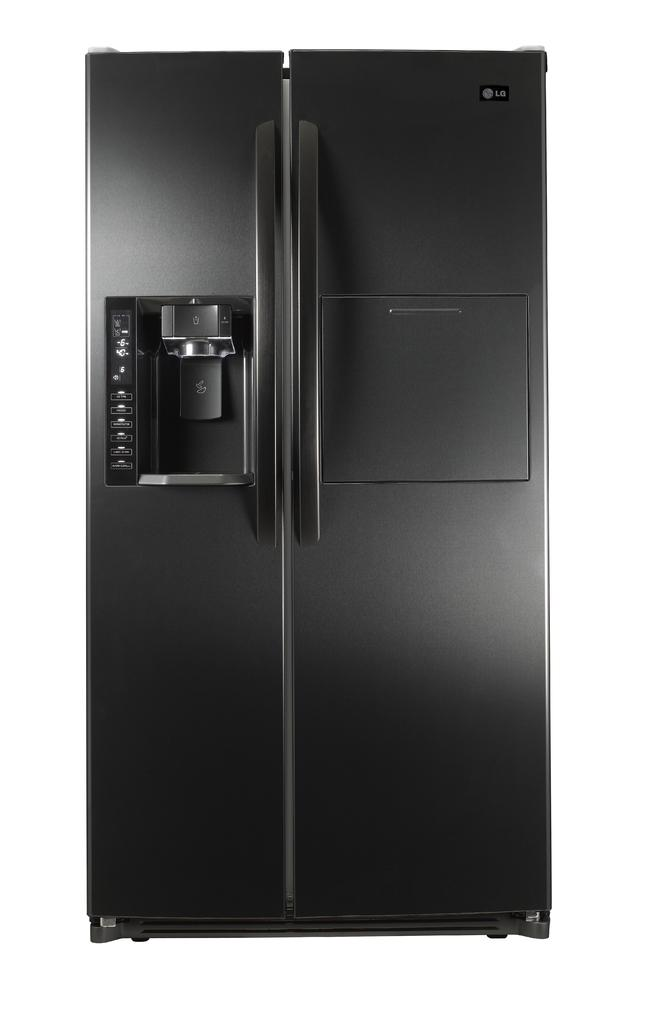What type of appliance is visible in the image? There is a refrigerator in the image. What feature is present on the refrigerator for opening and closing it? There are door handles on the refrigerator. Is there any branding or identification on the refrigerator? Yes, there is a logo at the top right of the refrigerator. What type of jelly can be seen growing on the refrigerator in the image? There is no jelly present on the refrigerator in the image. Can you describe the plant that is growing on the refrigerator in the image? There is no plant growing on the refrigerator in the image. 